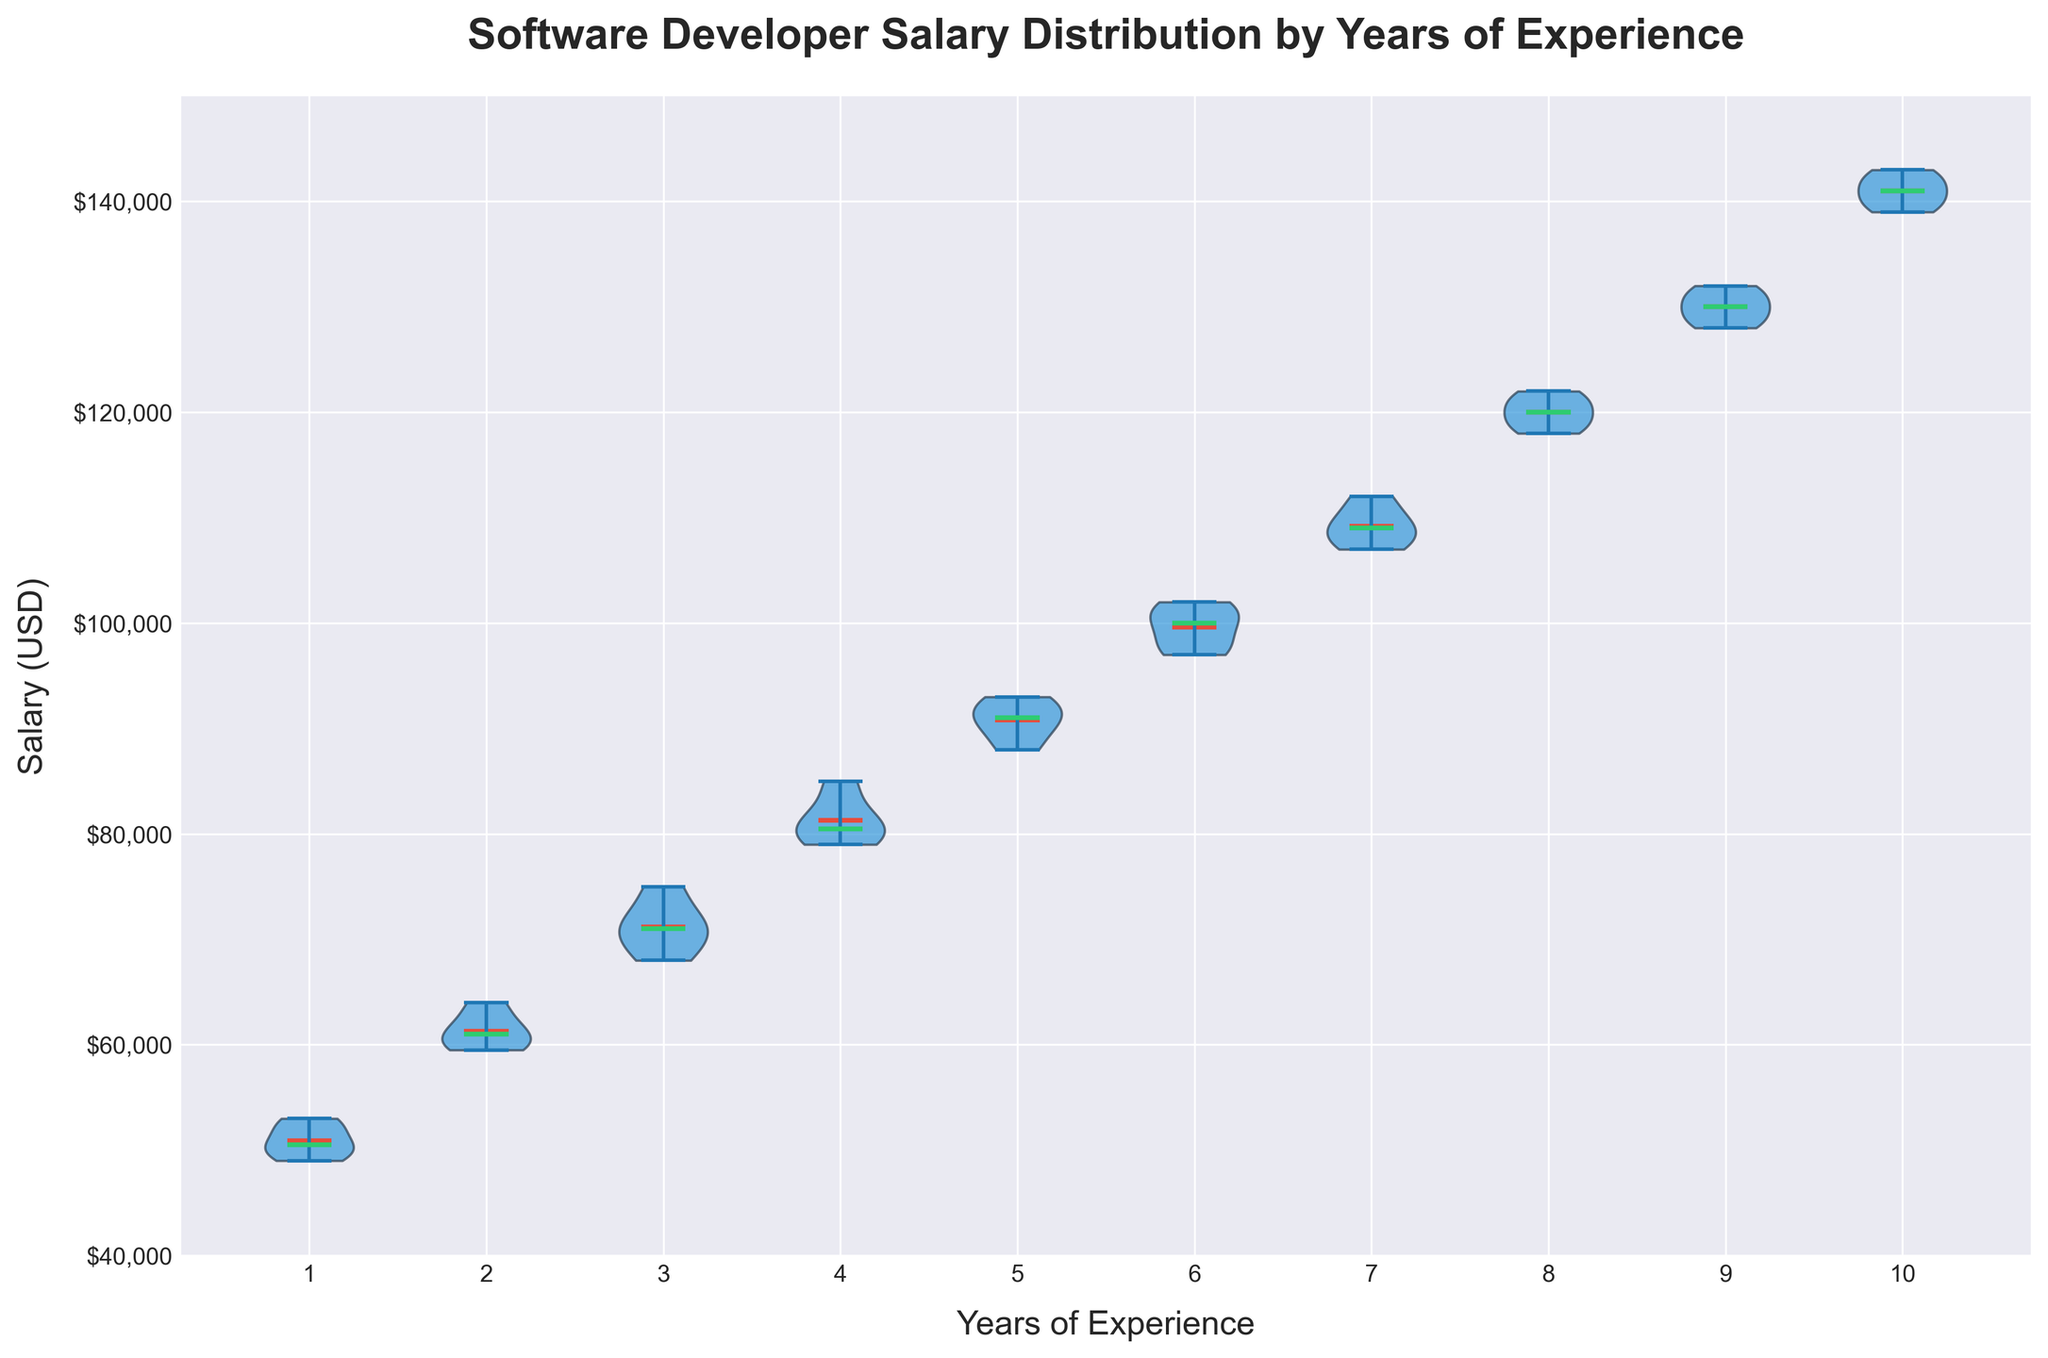What's the title of the figure? The title of the figure is written at the top of the plot, and it reads "Software Developer Salary Distribution by Years of Experience".
Answer: Software Developer Salary Distribution by Years of Experience Which visual element represents the mean salary for each experience level? The plot legend indicates that the mean salary for each experience level is represented by a horizontal line in red.
Answer: A horizontal line in red What is the range of salaries for software developers with 1 year of experience? The violins for developers with 1 year of experience span from the lowest point to the highest point on the y-axis. The range is from $49,000 to $53,000.
Answer: $49,000 to $53,000 What's the median salary for software developers with 5 years of experience? The violin plot includes a special horizontal line in green that represents the median salary for each experience level. For software developers with 5 years of experience, you'll see this green line spans around $91,000.
Answer: $91,000 How does the salary variability change with years of experience? The figure shows the width of each violin plot, which represents the salary variability for different experience levels. As the years of experience increase from 1 to 10, the widths of the violins appear to generally narrow, indicating a decrease in salary variability.
Answer: Decreases What is the difference between the median salaries for developers with 3 and 7 years of experience? The median salary for 3 years of experience is shown by the green horizontal line around $71,000, and for 7 years, it's around $109,000. The difference is calculated as $109,000 - $71,000 = $38,000.
Answer: $38,000 Between developers with 6 and 9 years of experience, which group has a higher mean salary? The mean salary is signified by a red line on each violin. Comparing these lines for 6 and 9 years of experience, the mean for 9 years is slightly higher, around $130,000, while for 6 years it's around $101,000 to $102,000.
Answer: Developers with 9 years of experience What is the salary range for software developers with 10 years of experience? By observing the width of the violin at the 10 years mark, the salary spans from about $139,000 to $143,000.
Answer: $139,000 to $143,000 Which experience level has the highest salary range? The highest salary range can be deduced from the violin plot with the greatest width. For instance, the 1-year experience level violin spans the largest salary range from $49,000 to $53,000.
Answer: 1-year experience level How can you identify outliers in this violin plot? The violin plot shows outliers as points that fall outside the range of the violin shapes. None are clearly depicted, suggesting no outliers in the provided data range.
Answer: Not visibly shown 